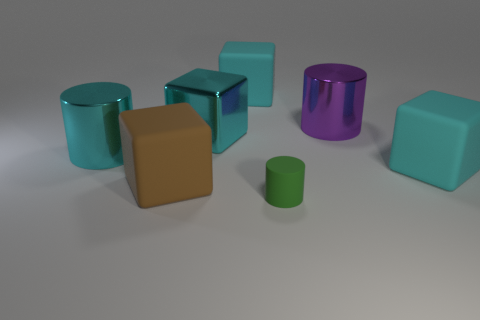What shape is the green matte object in front of the big cylinder on the left side of the purple metallic thing?
Offer a terse response. Cylinder. What number of other objects are there of the same material as the big cyan cylinder?
Ensure brevity in your answer.  2. Is the tiny thing made of the same material as the big cylinder that is on the right side of the rubber cylinder?
Provide a succinct answer. No. How many things are large shiny cylinders on the left side of the tiny green matte thing or big cyan matte objects that are right of the metallic block?
Offer a very short reply. 3. How many other things are there of the same color as the metallic block?
Make the answer very short. 3. Are there more cyan blocks that are in front of the big purple thing than purple shiny cylinders that are on the right side of the cyan metal cube?
Provide a succinct answer. Yes. Is there any other thing that is the same size as the green cylinder?
Offer a very short reply. No. What number of cylinders are large objects or purple things?
Your response must be concise. 2. How many objects are large matte things that are in front of the large purple metallic thing or big cyan cylinders?
Give a very brief answer. 3. There is a large rubber object to the left of the big rubber thing behind the cyan metal thing in front of the metallic block; what shape is it?
Offer a terse response. Cube. 